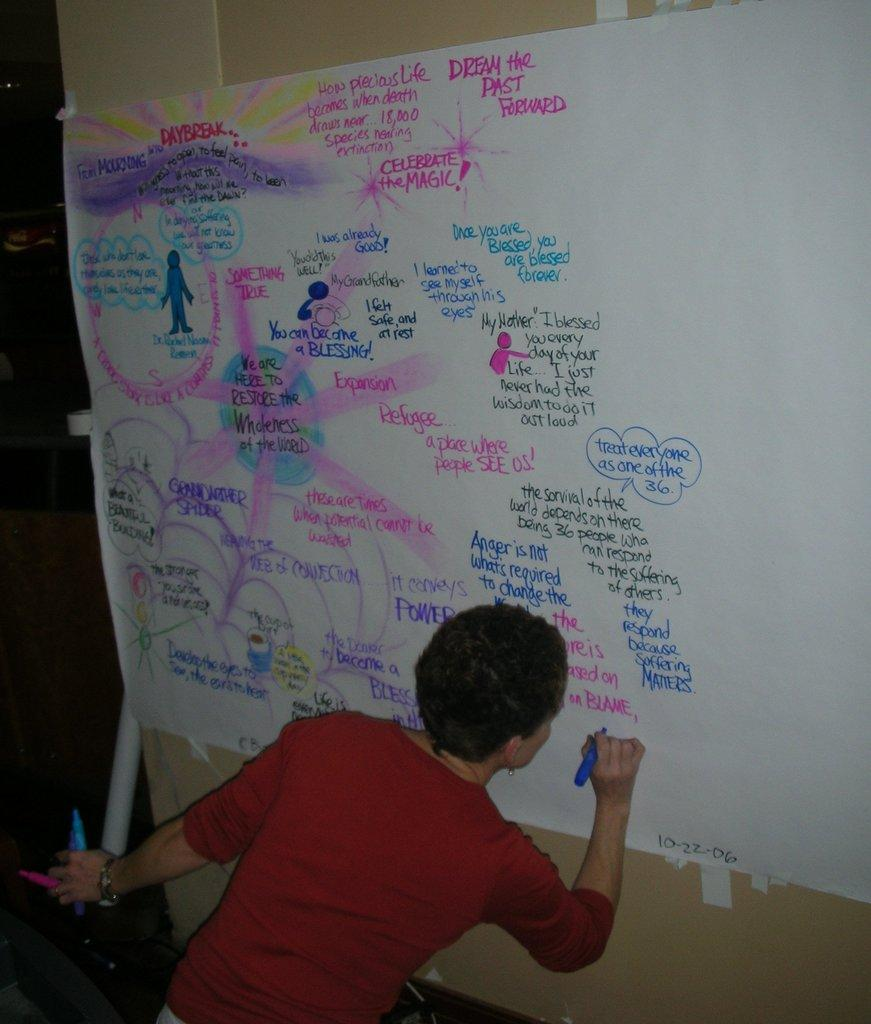What is the person in the image doing? The person is writing on a chart. Can you describe the chart in the image? There is a rolled chart at the left side of the image. What is the person holding in his hands? The person is holding pens in his hands. What type of meat is being served in the image? There is no meat present in the image; it features a person writing on a chart. Is the person driving a vehicle in the image? No, the person is not driving a vehicle in the image; they are writing on a chart. 